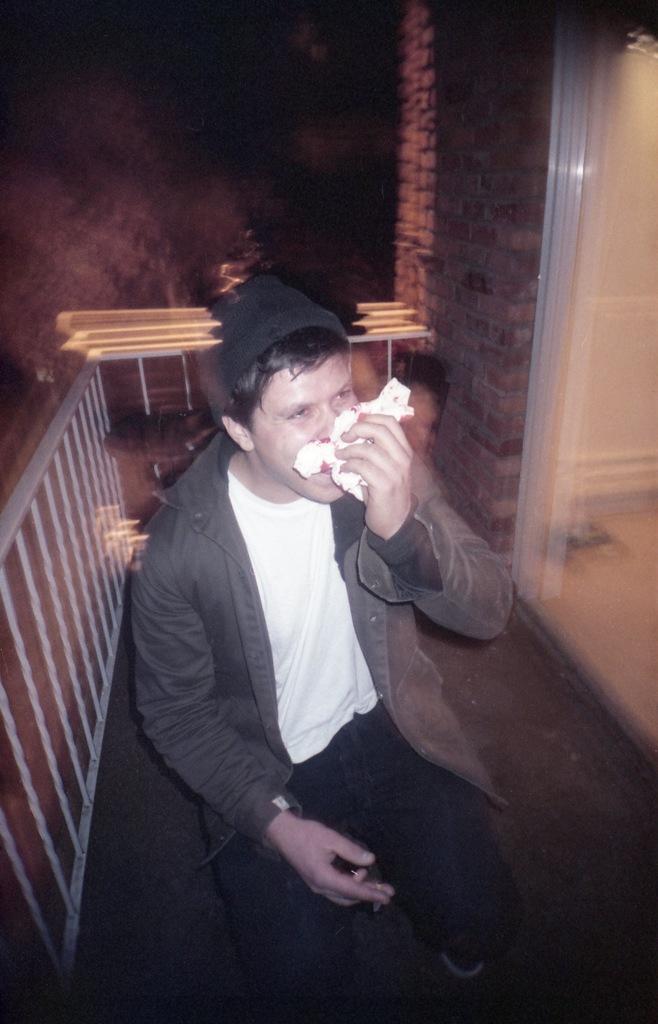Please provide a concise description of this image. In this image we can see a person sitting and covering his nose with a handkerchief. On the backside we can see some stairs and a wall. 